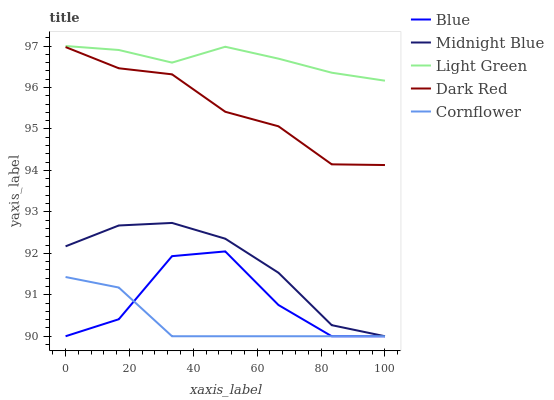Does Cornflower have the minimum area under the curve?
Answer yes or no. Yes. Does Light Green have the maximum area under the curve?
Answer yes or no. Yes. Does Dark Red have the minimum area under the curve?
Answer yes or no. No. Does Dark Red have the maximum area under the curve?
Answer yes or no. No. Is Light Green the smoothest?
Answer yes or no. Yes. Is Blue the roughest?
Answer yes or no. Yes. Is Dark Red the smoothest?
Answer yes or no. No. Is Dark Red the roughest?
Answer yes or no. No. Does Blue have the lowest value?
Answer yes or no. Yes. Does Dark Red have the lowest value?
Answer yes or no. No. Does Light Green have the highest value?
Answer yes or no. Yes. Does Dark Red have the highest value?
Answer yes or no. No. Is Blue less than Light Green?
Answer yes or no. Yes. Is Light Green greater than Dark Red?
Answer yes or no. Yes. Does Blue intersect Cornflower?
Answer yes or no. Yes. Is Blue less than Cornflower?
Answer yes or no. No. Is Blue greater than Cornflower?
Answer yes or no. No. Does Blue intersect Light Green?
Answer yes or no. No. 